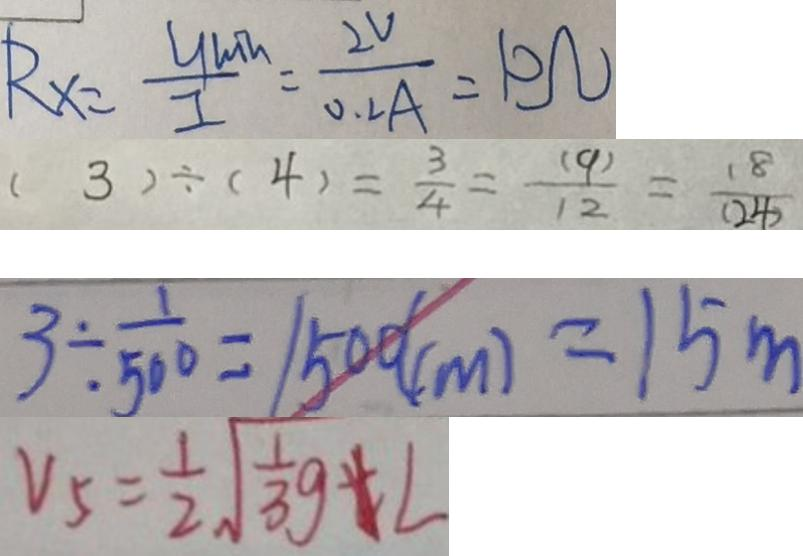<formula> <loc_0><loc_0><loc_500><loc_500>R _ { x } = \frac { y m h } { I } = \frac { 2 v } { 0 . 2 A } = 1 0 \Omega 
 ( 3 ) \div ( 4 ) = \frac { 3 } { 4 } = \frac { ( 9 ) } { 1 2 } = \frac { 1 8 } { ( 2 4 ) } 
 3 \div \frac { 1 } { 5 0 0 } = 1 5 0 ( c m ) = 1 5 m 
 V _ { 5 } = \frac { 1 } { 2 } \sqrt { \frac { 1 } { 3 } g } + L</formula> 